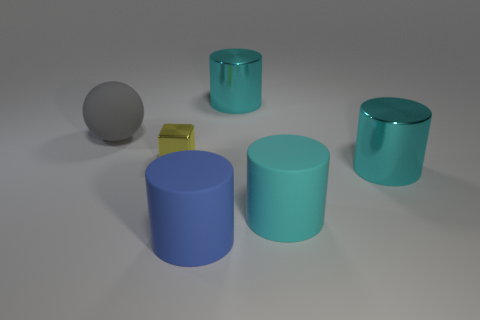Subtract all cyan cylinders. How many were subtracted if there are1cyan cylinders left? 2 Subtract all yellow spheres. How many cyan cylinders are left? 3 Add 1 cyan matte things. How many objects exist? 7 Subtract all spheres. How many objects are left? 5 Subtract all big blue objects. Subtract all large gray things. How many objects are left? 4 Add 1 big cyan metallic cylinders. How many big cyan metallic cylinders are left? 3 Add 4 blue objects. How many blue objects exist? 5 Subtract 1 blue cylinders. How many objects are left? 5 